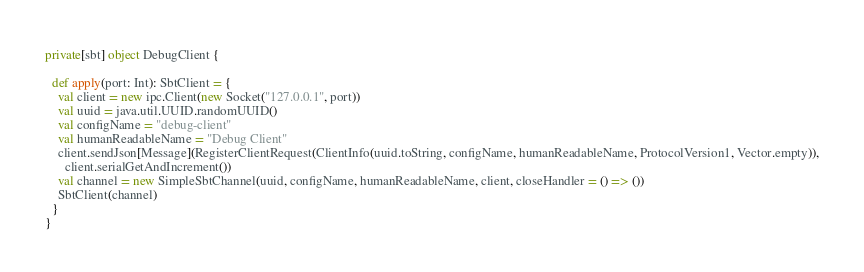<code> <loc_0><loc_0><loc_500><loc_500><_Scala_>private[sbt] object DebugClient {

  def apply(port: Int): SbtClient = {
    val client = new ipc.Client(new Socket("127.0.0.1", port))
    val uuid = java.util.UUID.randomUUID()
    val configName = "debug-client"
    val humanReadableName = "Debug Client"
    client.sendJson[Message](RegisterClientRequest(ClientInfo(uuid.toString, configName, humanReadableName, ProtocolVersion1, Vector.empty)),
      client.serialGetAndIncrement())
    val channel = new SimpleSbtChannel(uuid, configName, humanReadableName, client, closeHandler = () => ())
    SbtClient(channel)
  }
}
</code> 